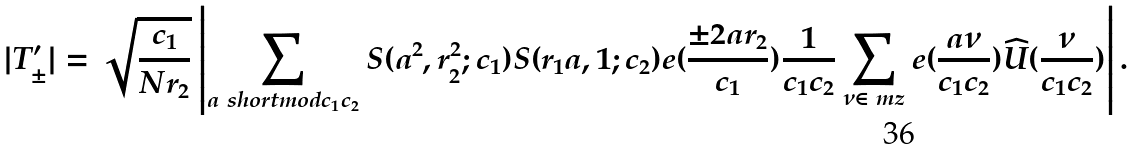Convert formula to latex. <formula><loc_0><loc_0><loc_500><loc_500>| T _ { \pm } ^ { \prime } | = \sqrt { \frac { c _ { 1 } } { N r _ { 2 } } } \left | \sum _ { a \ s h o r t m o d { c _ { 1 } c _ { 2 } } } S ( a ^ { 2 } , r _ { 2 } ^ { 2 } ; c _ { 1 } ) S ( r _ { 1 } a , 1 ; c _ { 2 } ) e ( \frac { \pm 2 a r _ { 2 } } { c _ { 1 } } ) \frac { 1 } { c _ { 1 } c _ { 2 } } \sum _ { \nu \in \ m z } e ( \frac { a \nu } { c _ { 1 } c _ { 2 } } ) \widehat { U } ( \frac { \nu } { c _ { 1 } c _ { 2 } } ) \right | .</formula> 